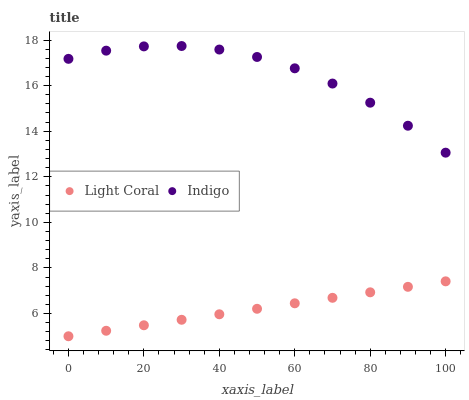Does Light Coral have the minimum area under the curve?
Answer yes or no. Yes. Does Indigo have the maximum area under the curve?
Answer yes or no. Yes. Does Indigo have the minimum area under the curve?
Answer yes or no. No. Is Light Coral the smoothest?
Answer yes or no. Yes. Is Indigo the roughest?
Answer yes or no. Yes. Is Indigo the smoothest?
Answer yes or no. No. Does Light Coral have the lowest value?
Answer yes or no. Yes. Does Indigo have the lowest value?
Answer yes or no. No. Does Indigo have the highest value?
Answer yes or no. Yes. Is Light Coral less than Indigo?
Answer yes or no. Yes. Is Indigo greater than Light Coral?
Answer yes or no. Yes. Does Light Coral intersect Indigo?
Answer yes or no. No. 